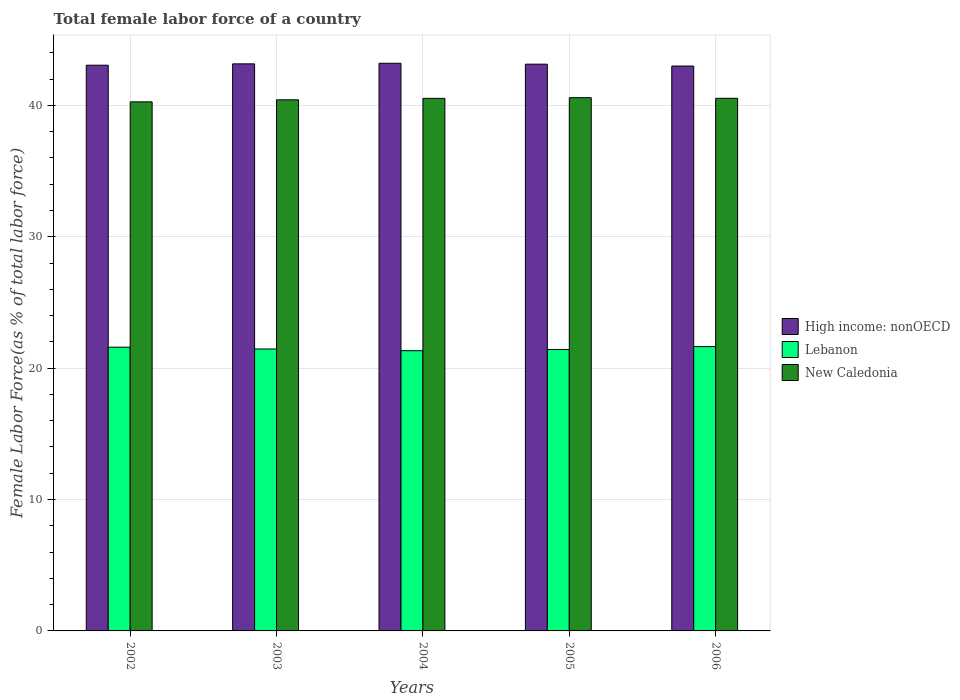How many bars are there on the 5th tick from the left?
Keep it short and to the point. 3. How many bars are there on the 5th tick from the right?
Offer a terse response. 3. What is the label of the 3rd group of bars from the left?
Your answer should be compact. 2004. What is the percentage of female labor force in Lebanon in 2005?
Keep it short and to the point. 21.42. Across all years, what is the maximum percentage of female labor force in High income: nonOECD?
Ensure brevity in your answer.  43.21. Across all years, what is the minimum percentage of female labor force in Lebanon?
Provide a succinct answer. 21.33. In which year was the percentage of female labor force in New Caledonia maximum?
Keep it short and to the point. 2005. What is the total percentage of female labor force in Lebanon in the graph?
Your response must be concise. 107.45. What is the difference between the percentage of female labor force in High income: nonOECD in 2002 and that in 2004?
Your answer should be compact. -0.15. What is the difference between the percentage of female labor force in Lebanon in 2003 and the percentage of female labor force in New Caledonia in 2002?
Give a very brief answer. -18.81. What is the average percentage of female labor force in Lebanon per year?
Make the answer very short. 21.49. In the year 2006, what is the difference between the percentage of female labor force in High income: nonOECD and percentage of female labor force in New Caledonia?
Ensure brevity in your answer.  2.46. In how many years, is the percentage of female labor force in New Caledonia greater than 2 %?
Ensure brevity in your answer.  5. What is the ratio of the percentage of female labor force in High income: nonOECD in 2002 to that in 2003?
Offer a very short reply. 1. What is the difference between the highest and the second highest percentage of female labor force in New Caledonia?
Your answer should be very brief. 0.05. What is the difference between the highest and the lowest percentage of female labor force in High income: nonOECD?
Provide a short and direct response. 0.21. What does the 2nd bar from the left in 2005 represents?
Keep it short and to the point. Lebanon. What does the 2nd bar from the right in 2004 represents?
Provide a succinct answer. Lebanon. How many bars are there?
Make the answer very short. 15. Are all the bars in the graph horizontal?
Your answer should be very brief. No. Are the values on the major ticks of Y-axis written in scientific E-notation?
Your answer should be very brief. No. Does the graph contain any zero values?
Your answer should be compact. No. Where does the legend appear in the graph?
Your answer should be compact. Center right. What is the title of the graph?
Make the answer very short. Total female labor force of a country. Does "Hungary" appear as one of the legend labels in the graph?
Keep it short and to the point. No. What is the label or title of the X-axis?
Keep it short and to the point. Years. What is the label or title of the Y-axis?
Your response must be concise. Female Labor Force(as % of total labor force). What is the Female Labor Force(as % of total labor force) in High income: nonOECD in 2002?
Offer a terse response. 43.06. What is the Female Labor Force(as % of total labor force) in Lebanon in 2002?
Provide a succinct answer. 21.6. What is the Female Labor Force(as % of total labor force) in New Caledonia in 2002?
Your answer should be very brief. 40.27. What is the Female Labor Force(as % of total labor force) in High income: nonOECD in 2003?
Provide a succinct answer. 43.16. What is the Female Labor Force(as % of total labor force) of Lebanon in 2003?
Make the answer very short. 21.46. What is the Female Labor Force(as % of total labor force) in New Caledonia in 2003?
Your answer should be compact. 40.43. What is the Female Labor Force(as % of total labor force) in High income: nonOECD in 2004?
Your answer should be compact. 43.21. What is the Female Labor Force(as % of total labor force) of Lebanon in 2004?
Your response must be concise. 21.33. What is the Female Labor Force(as % of total labor force) in New Caledonia in 2004?
Ensure brevity in your answer.  40.54. What is the Female Labor Force(as % of total labor force) of High income: nonOECD in 2005?
Your answer should be compact. 43.14. What is the Female Labor Force(as % of total labor force) in Lebanon in 2005?
Offer a very short reply. 21.42. What is the Female Labor Force(as % of total labor force) in New Caledonia in 2005?
Give a very brief answer. 40.59. What is the Female Labor Force(as % of total labor force) in High income: nonOECD in 2006?
Make the answer very short. 43. What is the Female Labor Force(as % of total labor force) of Lebanon in 2006?
Give a very brief answer. 21.64. What is the Female Labor Force(as % of total labor force) in New Caledonia in 2006?
Give a very brief answer. 40.54. Across all years, what is the maximum Female Labor Force(as % of total labor force) in High income: nonOECD?
Make the answer very short. 43.21. Across all years, what is the maximum Female Labor Force(as % of total labor force) of Lebanon?
Offer a terse response. 21.64. Across all years, what is the maximum Female Labor Force(as % of total labor force) in New Caledonia?
Ensure brevity in your answer.  40.59. Across all years, what is the minimum Female Labor Force(as % of total labor force) in High income: nonOECD?
Offer a terse response. 43. Across all years, what is the minimum Female Labor Force(as % of total labor force) of Lebanon?
Provide a succinct answer. 21.33. Across all years, what is the minimum Female Labor Force(as % of total labor force) of New Caledonia?
Ensure brevity in your answer.  40.27. What is the total Female Labor Force(as % of total labor force) of High income: nonOECD in the graph?
Keep it short and to the point. 215.57. What is the total Female Labor Force(as % of total labor force) in Lebanon in the graph?
Your response must be concise. 107.45. What is the total Female Labor Force(as % of total labor force) of New Caledonia in the graph?
Offer a very short reply. 202.37. What is the difference between the Female Labor Force(as % of total labor force) of High income: nonOECD in 2002 and that in 2003?
Ensure brevity in your answer.  -0.1. What is the difference between the Female Labor Force(as % of total labor force) of Lebanon in 2002 and that in 2003?
Provide a succinct answer. 0.14. What is the difference between the Female Labor Force(as % of total labor force) in New Caledonia in 2002 and that in 2003?
Your answer should be compact. -0.16. What is the difference between the Female Labor Force(as % of total labor force) of High income: nonOECD in 2002 and that in 2004?
Offer a very short reply. -0.15. What is the difference between the Female Labor Force(as % of total labor force) in Lebanon in 2002 and that in 2004?
Your answer should be compact. 0.27. What is the difference between the Female Labor Force(as % of total labor force) of New Caledonia in 2002 and that in 2004?
Ensure brevity in your answer.  -0.27. What is the difference between the Female Labor Force(as % of total labor force) of High income: nonOECD in 2002 and that in 2005?
Your answer should be compact. -0.08. What is the difference between the Female Labor Force(as % of total labor force) of Lebanon in 2002 and that in 2005?
Give a very brief answer. 0.18. What is the difference between the Female Labor Force(as % of total labor force) of New Caledonia in 2002 and that in 2005?
Offer a very short reply. -0.32. What is the difference between the Female Labor Force(as % of total labor force) of High income: nonOECD in 2002 and that in 2006?
Your response must be concise. 0.06. What is the difference between the Female Labor Force(as % of total labor force) in Lebanon in 2002 and that in 2006?
Provide a succinct answer. -0.04. What is the difference between the Female Labor Force(as % of total labor force) of New Caledonia in 2002 and that in 2006?
Provide a succinct answer. -0.27. What is the difference between the Female Labor Force(as % of total labor force) of High income: nonOECD in 2003 and that in 2004?
Give a very brief answer. -0.05. What is the difference between the Female Labor Force(as % of total labor force) in Lebanon in 2003 and that in 2004?
Your answer should be compact. 0.13. What is the difference between the Female Labor Force(as % of total labor force) of New Caledonia in 2003 and that in 2004?
Your response must be concise. -0.11. What is the difference between the Female Labor Force(as % of total labor force) of High income: nonOECD in 2003 and that in 2005?
Offer a terse response. 0.02. What is the difference between the Female Labor Force(as % of total labor force) of Lebanon in 2003 and that in 2005?
Ensure brevity in your answer.  0.04. What is the difference between the Female Labor Force(as % of total labor force) of New Caledonia in 2003 and that in 2005?
Ensure brevity in your answer.  -0.16. What is the difference between the Female Labor Force(as % of total labor force) of High income: nonOECD in 2003 and that in 2006?
Give a very brief answer. 0.17. What is the difference between the Female Labor Force(as % of total labor force) of Lebanon in 2003 and that in 2006?
Make the answer very short. -0.18. What is the difference between the Female Labor Force(as % of total labor force) of New Caledonia in 2003 and that in 2006?
Offer a very short reply. -0.11. What is the difference between the Female Labor Force(as % of total labor force) of High income: nonOECD in 2004 and that in 2005?
Offer a very short reply. 0.07. What is the difference between the Female Labor Force(as % of total labor force) of Lebanon in 2004 and that in 2005?
Provide a succinct answer. -0.09. What is the difference between the Female Labor Force(as % of total labor force) in New Caledonia in 2004 and that in 2005?
Provide a succinct answer. -0.05. What is the difference between the Female Labor Force(as % of total labor force) of High income: nonOECD in 2004 and that in 2006?
Keep it short and to the point. 0.21. What is the difference between the Female Labor Force(as % of total labor force) in Lebanon in 2004 and that in 2006?
Keep it short and to the point. -0.31. What is the difference between the Female Labor Force(as % of total labor force) of New Caledonia in 2004 and that in 2006?
Provide a succinct answer. -0. What is the difference between the Female Labor Force(as % of total labor force) of High income: nonOECD in 2005 and that in 2006?
Your response must be concise. 0.14. What is the difference between the Female Labor Force(as % of total labor force) in Lebanon in 2005 and that in 2006?
Make the answer very short. -0.22. What is the difference between the Female Labor Force(as % of total labor force) in New Caledonia in 2005 and that in 2006?
Your answer should be very brief. 0.05. What is the difference between the Female Labor Force(as % of total labor force) in High income: nonOECD in 2002 and the Female Labor Force(as % of total labor force) in Lebanon in 2003?
Keep it short and to the point. 21.6. What is the difference between the Female Labor Force(as % of total labor force) in High income: nonOECD in 2002 and the Female Labor Force(as % of total labor force) in New Caledonia in 2003?
Your answer should be very brief. 2.63. What is the difference between the Female Labor Force(as % of total labor force) of Lebanon in 2002 and the Female Labor Force(as % of total labor force) of New Caledonia in 2003?
Provide a succinct answer. -18.83. What is the difference between the Female Labor Force(as % of total labor force) of High income: nonOECD in 2002 and the Female Labor Force(as % of total labor force) of Lebanon in 2004?
Offer a terse response. 21.73. What is the difference between the Female Labor Force(as % of total labor force) in High income: nonOECD in 2002 and the Female Labor Force(as % of total labor force) in New Caledonia in 2004?
Give a very brief answer. 2.52. What is the difference between the Female Labor Force(as % of total labor force) of Lebanon in 2002 and the Female Labor Force(as % of total labor force) of New Caledonia in 2004?
Provide a succinct answer. -18.94. What is the difference between the Female Labor Force(as % of total labor force) in High income: nonOECD in 2002 and the Female Labor Force(as % of total labor force) in Lebanon in 2005?
Offer a terse response. 21.64. What is the difference between the Female Labor Force(as % of total labor force) of High income: nonOECD in 2002 and the Female Labor Force(as % of total labor force) of New Caledonia in 2005?
Your response must be concise. 2.47. What is the difference between the Female Labor Force(as % of total labor force) of Lebanon in 2002 and the Female Labor Force(as % of total labor force) of New Caledonia in 2005?
Keep it short and to the point. -18.99. What is the difference between the Female Labor Force(as % of total labor force) of High income: nonOECD in 2002 and the Female Labor Force(as % of total labor force) of Lebanon in 2006?
Make the answer very short. 21.42. What is the difference between the Female Labor Force(as % of total labor force) in High income: nonOECD in 2002 and the Female Labor Force(as % of total labor force) in New Caledonia in 2006?
Ensure brevity in your answer.  2.52. What is the difference between the Female Labor Force(as % of total labor force) in Lebanon in 2002 and the Female Labor Force(as % of total labor force) in New Caledonia in 2006?
Make the answer very short. -18.94. What is the difference between the Female Labor Force(as % of total labor force) in High income: nonOECD in 2003 and the Female Labor Force(as % of total labor force) in Lebanon in 2004?
Offer a terse response. 21.83. What is the difference between the Female Labor Force(as % of total labor force) of High income: nonOECD in 2003 and the Female Labor Force(as % of total labor force) of New Caledonia in 2004?
Keep it short and to the point. 2.63. What is the difference between the Female Labor Force(as % of total labor force) of Lebanon in 2003 and the Female Labor Force(as % of total labor force) of New Caledonia in 2004?
Offer a very short reply. -19.08. What is the difference between the Female Labor Force(as % of total labor force) in High income: nonOECD in 2003 and the Female Labor Force(as % of total labor force) in Lebanon in 2005?
Your answer should be very brief. 21.74. What is the difference between the Female Labor Force(as % of total labor force) in High income: nonOECD in 2003 and the Female Labor Force(as % of total labor force) in New Caledonia in 2005?
Make the answer very short. 2.57. What is the difference between the Female Labor Force(as % of total labor force) of Lebanon in 2003 and the Female Labor Force(as % of total labor force) of New Caledonia in 2005?
Ensure brevity in your answer.  -19.13. What is the difference between the Female Labor Force(as % of total labor force) in High income: nonOECD in 2003 and the Female Labor Force(as % of total labor force) in Lebanon in 2006?
Your response must be concise. 21.52. What is the difference between the Female Labor Force(as % of total labor force) of High income: nonOECD in 2003 and the Female Labor Force(as % of total labor force) of New Caledonia in 2006?
Your answer should be very brief. 2.62. What is the difference between the Female Labor Force(as % of total labor force) of Lebanon in 2003 and the Female Labor Force(as % of total labor force) of New Caledonia in 2006?
Provide a succinct answer. -19.08. What is the difference between the Female Labor Force(as % of total labor force) in High income: nonOECD in 2004 and the Female Labor Force(as % of total labor force) in Lebanon in 2005?
Offer a very short reply. 21.79. What is the difference between the Female Labor Force(as % of total labor force) of High income: nonOECD in 2004 and the Female Labor Force(as % of total labor force) of New Caledonia in 2005?
Offer a terse response. 2.62. What is the difference between the Female Labor Force(as % of total labor force) of Lebanon in 2004 and the Female Labor Force(as % of total labor force) of New Caledonia in 2005?
Provide a short and direct response. -19.26. What is the difference between the Female Labor Force(as % of total labor force) of High income: nonOECD in 2004 and the Female Labor Force(as % of total labor force) of Lebanon in 2006?
Make the answer very short. 21.57. What is the difference between the Female Labor Force(as % of total labor force) of High income: nonOECD in 2004 and the Female Labor Force(as % of total labor force) of New Caledonia in 2006?
Make the answer very short. 2.67. What is the difference between the Female Labor Force(as % of total labor force) of Lebanon in 2004 and the Female Labor Force(as % of total labor force) of New Caledonia in 2006?
Your answer should be very brief. -19.21. What is the difference between the Female Labor Force(as % of total labor force) in High income: nonOECD in 2005 and the Female Labor Force(as % of total labor force) in Lebanon in 2006?
Provide a succinct answer. 21.5. What is the difference between the Female Labor Force(as % of total labor force) in High income: nonOECD in 2005 and the Female Labor Force(as % of total labor force) in New Caledonia in 2006?
Offer a terse response. 2.6. What is the difference between the Female Labor Force(as % of total labor force) of Lebanon in 2005 and the Female Labor Force(as % of total labor force) of New Caledonia in 2006?
Make the answer very short. -19.12. What is the average Female Labor Force(as % of total labor force) in High income: nonOECD per year?
Give a very brief answer. 43.11. What is the average Female Labor Force(as % of total labor force) in Lebanon per year?
Your answer should be compact. 21.49. What is the average Female Labor Force(as % of total labor force) in New Caledonia per year?
Ensure brevity in your answer.  40.47. In the year 2002, what is the difference between the Female Labor Force(as % of total labor force) in High income: nonOECD and Female Labor Force(as % of total labor force) in Lebanon?
Offer a terse response. 21.46. In the year 2002, what is the difference between the Female Labor Force(as % of total labor force) in High income: nonOECD and Female Labor Force(as % of total labor force) in New Caledonia?
Your response must be concise. 2.79. In the year 2002, what is the difference between the Female Labor Force(as % of total labor force) in Lebanon and Female Labor Force(as % of total labor force) in New Caledonia?
Provide a short and direct response. -18.67. In the year 2003, what is the difference between the Female Labor Force(as % of total labor force) of High income: nonOECD and Female Labor Force(as % of total labor force) of Lebanon?
Your response must be concise. 21.7. In the year 2003, what is the difference between the Female Labor Force(as % of total labor force) in High income: nonOECD and Female Labor Force(as % of total labor force) in New Caledonia?
Provide a succinct answer. 2.74. In the year 2003, what is the difference between the Female Labor Force(as % of total labor force) of Lebanon and Female Labor Force(as % of total labor force) of New Caledonia?
Your answer should be very brief. -18.97. In the year 2004, what is the difference between the Female Labor Force(as % of total labor force) in High income: nonOECD and Female Labor Force(as % of total labor force) in Lebanon?
Make the answer very short. 21.88. In the year 2004, what is the difference between the Female Labor Force(as % of total labor force) of High income: nonOECD and Female Labor Force(as % of total labor force) of New Caledonia?
Your response must be concise. 2.67. In the year 2004, what is the difference between the Female Labor Force(as % of total labor force) in Lebanon and Female Labor Force(as % of total labor force) in New Caledonia?
Your response must be concise. -19.21. In the year 2005, what is the difference between the Female Labor Force(as % of total labor force) in High income: nonOECD and Female Labor Force(as % of total labor force) in Lebanon?
Your response must be concise. 21.72. In the year 2005, what is the difference between the Female Labor Force(as % of total labor force) in High income: nonOECD and Female Labor Force(as % of total labor force) in New Caledonia?
Provide a short and direct response. 2.55. In the year 2005, what is the difference between the Female Labor Force(as % of total labor force) in Lebanon and Female Labor Force(as % of total labor force) in New Caledonia?
Offer a terse response. -19.17. In the year 2006, what is the difference between the Female Labor Force(as % of total labor force) in High income: nonOECD and Female Labor Force(as % of total labor force) in Lebanon?
Your answer should be very brief. 21.35. In the year 2006, what is the difference between the Female Labor Force(as % of total labor force) of High income: nonOECD and Female Labor Force(as % of total labor force) of New Caledonia?
Provide a short and direct response. 2.46. In the year 2006, what is the difference between the Female Labor Force(as % of total labor force) of Lebanon and Female Labor Force(as % of total labor force) of New Caledonia?
Give a very brief answer. -18.9. What is the ratio of the Female Labor Force(as % of total labor force) of High income: nonOECD in 2002 to that in 2003?
Your answer should be very brief. 1. What is the ratio of the Female Labor Force(as % of total labor force) of Lebanon in 2002 to that in 2003?
Ensure brevity in your answer.  1.01. What is the ratio of the Female Labor Force(as % of total labor force) of New Caledonia in 2002 to that in 2003?
Provide a short and direct response. 1. What is the ratio of the Female Labor Force(as % of total labor force) in High income: nonOECD in 2002 to that in 2004?
Make the answer very short. 1. What is the ratio of the Female Labor Force(as % of total labor force) of Lebanon in 2002 to that in 2004?
Offer a terse response. 1.01. What is the ratio of the Female Labor Force(as % of total labor force) in New Caledonia in 2002 to that in 2004?
Offer a terse response. 0.99. What is the ratio of the Female Labor Force(as % of total labor force) in High income: nonOECD in 2002 to that in 2005?
Provide a short and direct response. 1. What is the ratio of the Female Labor Force(as % of total labor force) in Lebanon in 2002 to that in 2005?
Give a very brief answer. 1.01. What is the ratio of the Female Labor Force(as % of total labor force) in Lebanon in 2002 to that in 2006?
Offer a very short reply. 1. What is the ratio of the Female Labor Force(as % of total labor force) in High income: nonOECD in 2003 to that in 2004?
Ensure brevity in your answer.  1. What is the ratio of the Female Labor Force(as % of total labor force) in Lebanon in 2003 to that in 2004?
Your response must be concise. 1.01. What is the ratio of the Female Labor Force(as % of total labor force) in High income: nonOECD in 2003 to that in 2005?
Provide a short and direct response. 1. What is the ratio of the Female Labor Force(as % of total labor force) of New Caledonia in 2003 to that in 2005?
Provide a short and direct response. 1. What is the ratio of the Female Labor Force(as % of total labor force) in Lebanon in 2003 to that in 2006?
Offer a very short reply. 0.99. What is the ratio of the Female Labor Force(as % of total labor force) in Lebanon in 2004 to that in 2006?
Provide a short and direct response. 0.99. What is the difference between the highest and the second highest Female Labor Force(as % of total labor force) in High income: nonOECD?
Make the answer very short. 0.05. What is the difference between the highest and the second highest Female Labor Force(as % of total labor force) in Lebanon?
Give a very brief answer. 0.04. What is the difference between the highest and the second highest Female Labor Force(as % of total labor force) in New Caledonia?
Your response must be concise. 0.05. What is the difference between the highest and the lowest Female Labor Force(as % of total labor force) of High income: nonOECD?
Make the answer very short. 0.21. What is the difference between the highest and the lowest Female Labor Force(as % of total labor force) in Lebanon?
Offer a terse response. 0.31. What is the difference between the highest and the lowest Female Labor Force(as % of total labor force) in New Caledonia?
Your answer should be very brief. 0.32. 